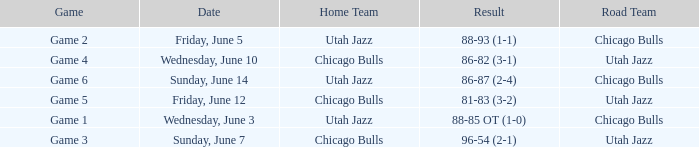What was the outcome of game 5's game? 81-83 (3-2). 